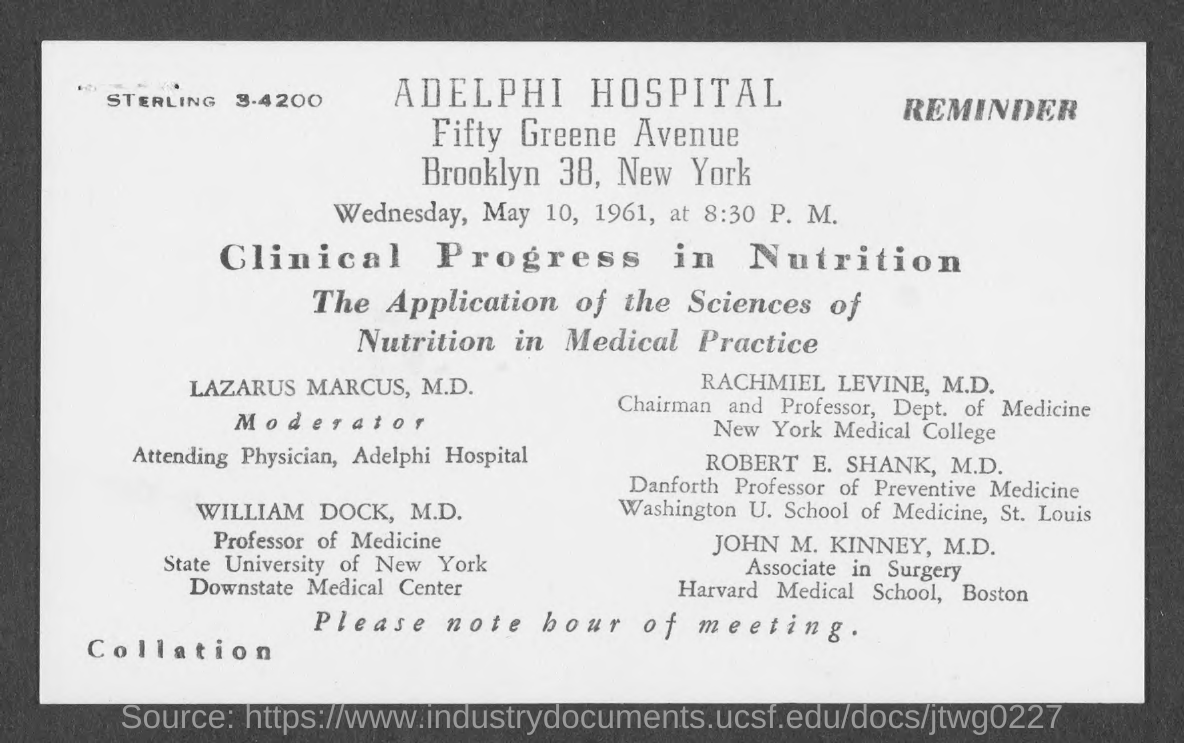Outline some significant characteristics in this image. The moderator is Lazarus Marcus. The meeting is scheduled to take place at 8:30 P.M. The meeting will take place on Wednesday, May 10, 1961. The meeting title is "Clinical Progress in Nutrition. 